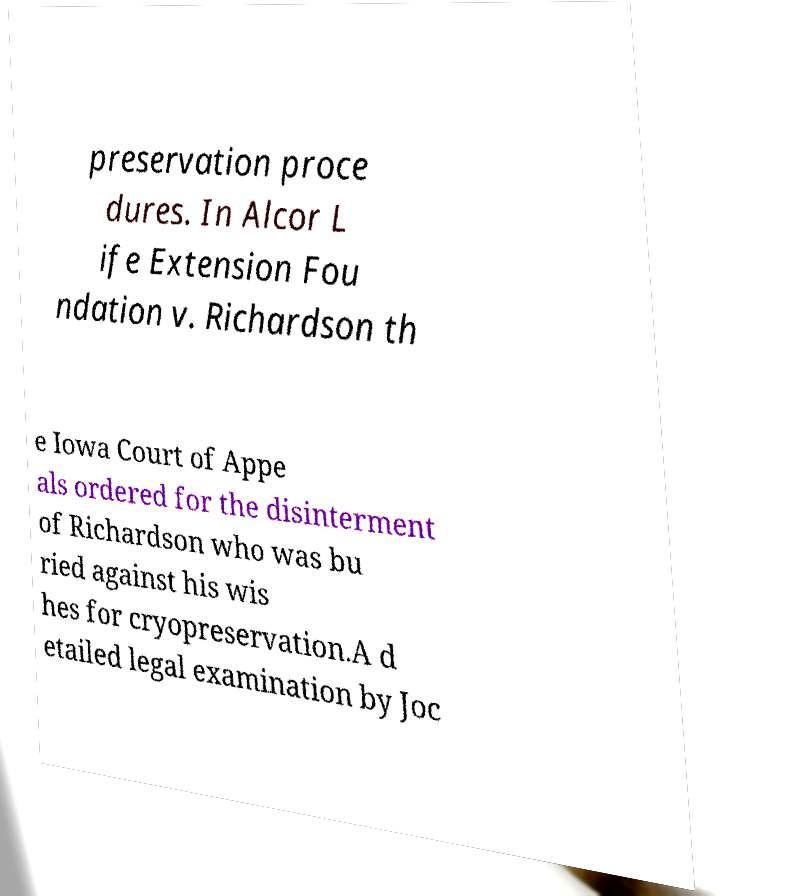Can you accurately transcribe the text from the provided image for me? preservation proce dures. In Alcor L ife Extension Fou ndation v. Richardson th e Iowa Court of Appe als ordered for the disinterment of Richardson who was bu ried against his wis hes for cryopreservation.A d etailed legal examination by Joc 